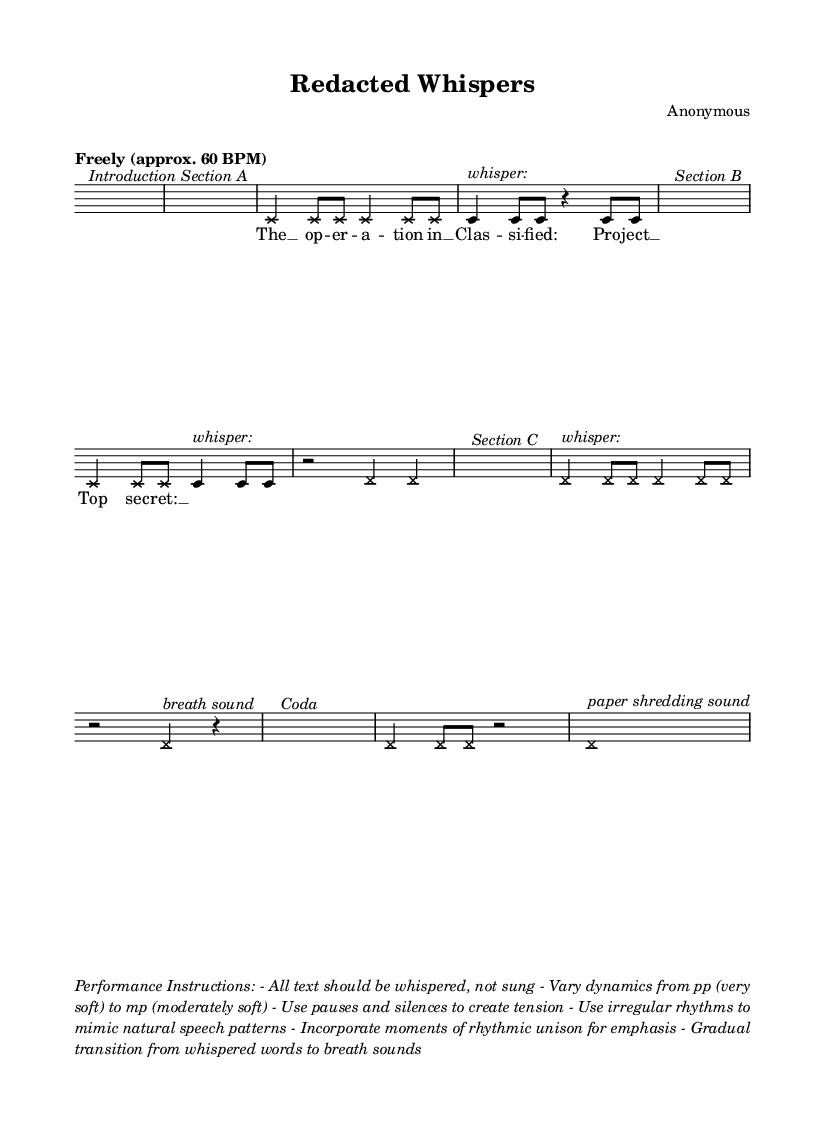What is the time signature of this music? The time signature is indicated by "4/4" at the beginning of the score. This means there are four beats in each measure.
Answer: 4/4 What is the tempo of the piece? The tempo is marked as "Freely (approx. 60 BPM)", which suggests a relaxed pace, allowing for flexible timing around 60 beats per minute.
Answer: Freely (approx. 60 BPM) How are the vocal parts treated in this composition? The composition specifies that all text should be whispered, indicating a non-traditional approach to vocal performance, deviating from singing.
Answer: Whispered What is indicated by the "shred" notation? The "shred" notation features a specific override for the note heads, indicating a visual representation meant to mimic the sound of paper shredding, suggesting an experimental audio effect.
Answer: Paper shredding sound What dynamics should the performer vary within the performance? The performance instructions state to vary dynamics from pp (very soft) to mp (moderately soft), indicating a range of volume should be explored within this music piece.
Answer: pp to mp What phrase signifies the end of the piece? The coda section leads to a concluding statement with the phrase "paper shredding sound", which signifies the end of the piece.
Answer: paper shredding sound What materials are suggested for use in the performance? The music indicates the use of whispering and breath sounds, which are core to creating the intended atmosphere and soundscape.
Answer: Whisper and breath sounds 